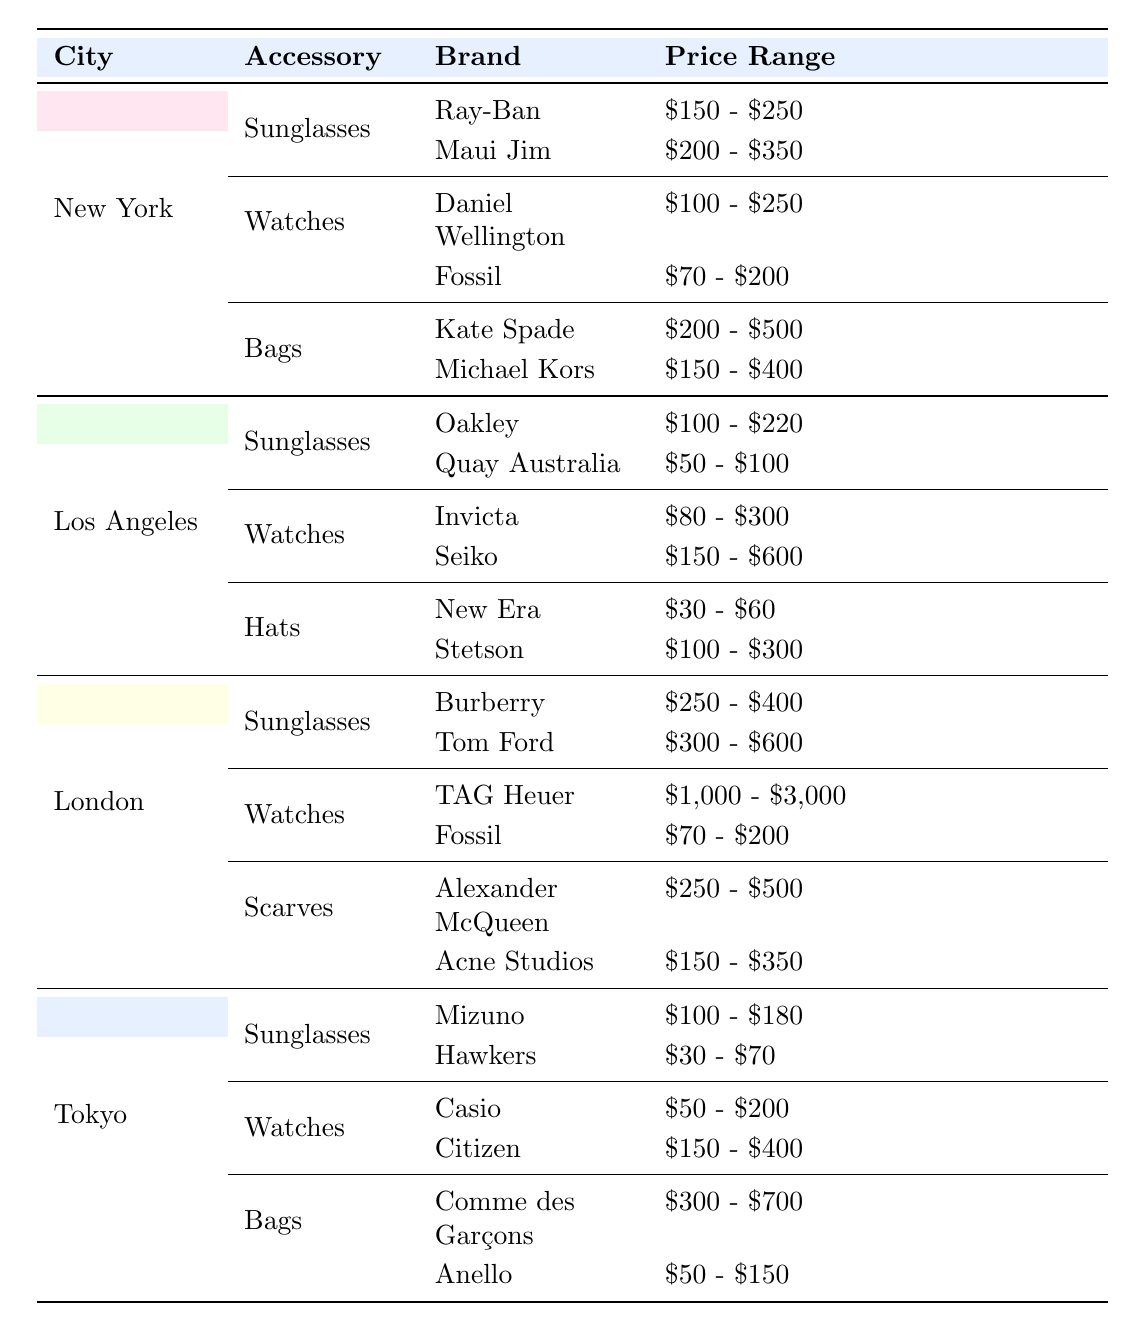What is the price range for Ray-Ban sunglasses in New York? The table specifies that Ray-Ban sunglasses in New York have a price range of $150 to $250.
Answer: $150 - $250 Which city has the highest price range for watches? In the table, London has the highest price range for watches, with TAG Heuer priced between $1,000 and $3,000. This far exceeds the price ranges listed for watches in other cities.
Answer: London Are there any hats listed in Tokyo? The table shows that Tokyo does not have any listed hats among the accessories. Therefore, the answer is no.
Answer: No What is the price range of bags from Comme des Garçons in Tokyo compared to Michael Kors in New York? The price range for bags from Comme des Garçons in Tokyo is $300 to $700, whereas Michael Kors in New York is $150 to $400. Since $300 to $700 starts higher than $150 to $400, it is clear that the former is more expensive.
Answer: Comme des Garçons is more expensive What is the average price range for sunglasses across all cities? The price ranges for sunglasses are as follows: New York - $150 to $350, Los Angeles - $50 to $220, London - $250 to $600, and Tokyo - $30 to $180. To find the average of the minimum prices: (150 + 50 + 250 + 30) / 4 = 120. To find the average of the maximum prices: (350 + 220 + 600 + 180) / 4 = 335. Thus, the average price range for sunglasses is $120 - $335.
Answer: $120 - $335 Which accessory is the least expensive by its price range in Los Angeles? In Los Angeles, the hats have the least expensive price range with New Era priced at $30 to $60 and Stetson at $100 to $300. The $30 to $60 range is the lowest when compared to glasses and watches listed in Los Angeles.
Answer: Hats (New Era) 